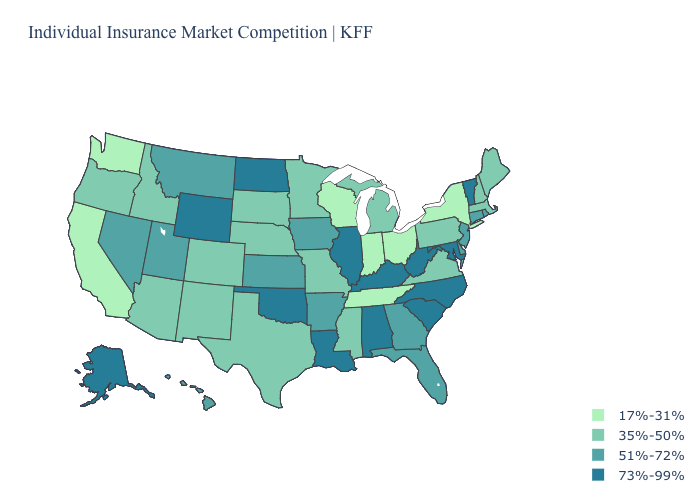Does the map have missing data?
Write a very short answer. No. Does Indiana have the lowest value in the MidWest?
Quick response, please. Yes. Name the states that have a value in the range 51%-72%?
Concise answer only. Arkansas, Connecticut, Delaware, Florida, Georgia, Hawaii, Iowa, Kansas, Montana, Nevada, New Jersey, Rhode Island, Utah. What is the value of Washington?
Be succinct. 17%-31%. Does New Mexico have the highest value in the West?
Answer briefly. No. What is the highest value in states that border Oregon?
Short answer required. 51%-72%. Does South Dakota have a lower value than Michigan?
Write a very short answer. No. Which states have the highest value in the USA?
Short answer required. Alabama, Alaska, Illinois, Kentucky, Louisiana, Maryland, North Carolina, North Dakota, Oklahoma, South Carolina, Vermont, West Virginia, Wyoming. Which states have the highest value in the USA?
Give a very brief answer. Alabama, Alaska, Illinois, Kentucky, Louisiana, Maryland, North Carolina, North Dakota, Oklahoma, South Carolina, Vermont, West Virginia, Wyoming. Which states hav the highest value in the Northeast?
Quick response, please. Vermont. Does Tennessee have a higher value than Alabama?
Short answer required. No. What is the highest value in the Northeast ?
Concise answer only. 73%-99%. Does Pennsylvania have the highest value in the Northeast?
Give a very brief answer. No. What is the value of Georgia?
Be succinct. 51%-72%. Which states hav the highest value in the MidWest?
Give a very brief answer. Illinois, North Dakota. 